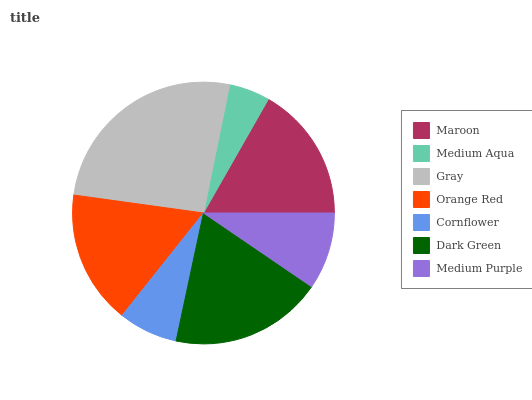Is Medium Aqua the minimum?
Answer yes or no. Yes. Is Gray the maximum?
Answer yes or no. Yes. Is Gray the minimum?
Answer yes or no. No. Is Medium Aqua the maximum?
Answer yes or no. No. Is Gray greater than Medium Aqua?
Answer yes or no. Yes. Is Medium Aqua less than Gray?
Answer yes or no. Yes. Is Medium Aqua greater than Gray?
Answer yes or no. No. Is Gray less than Medium Aqua?
Answer yes or no. No. Is Orange Red the high median?
Answer yes or no. Yes. Is Orange Red the low median?
Answer yes or no. Yes. Is Medium Aqua the high median?
Answer yes or no. No. Is Cornflower the low median?
Answer yes or no. No. 